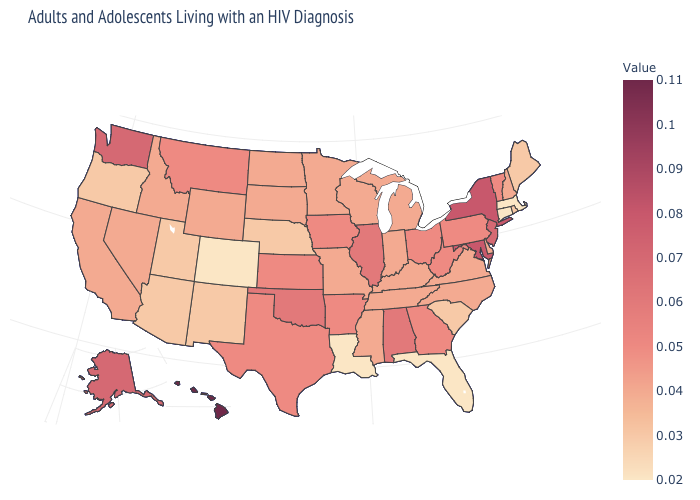Does the map have missing data?
Keep it brief. No. Among the states that border New York , which have the lowest value?
Write a very short answer. Connecticut, Massachusetts. Is the legend a continuous bar?
Concise answer only. Yes. Does Florida have the lowest value in the USA?
Be succinct. Yes. Does Oklahoma have the lowest value in the USA?
Give a very brief answer. No. Which states have the lowest value in the MidWest?
Write a very short answer. Nebraska. Which states hav the highest value in the MidWest?
Write a very short answer. Illinois. Among the states that border Ohio , does Michigan have the lowest value?
Be succinct. Yes. 